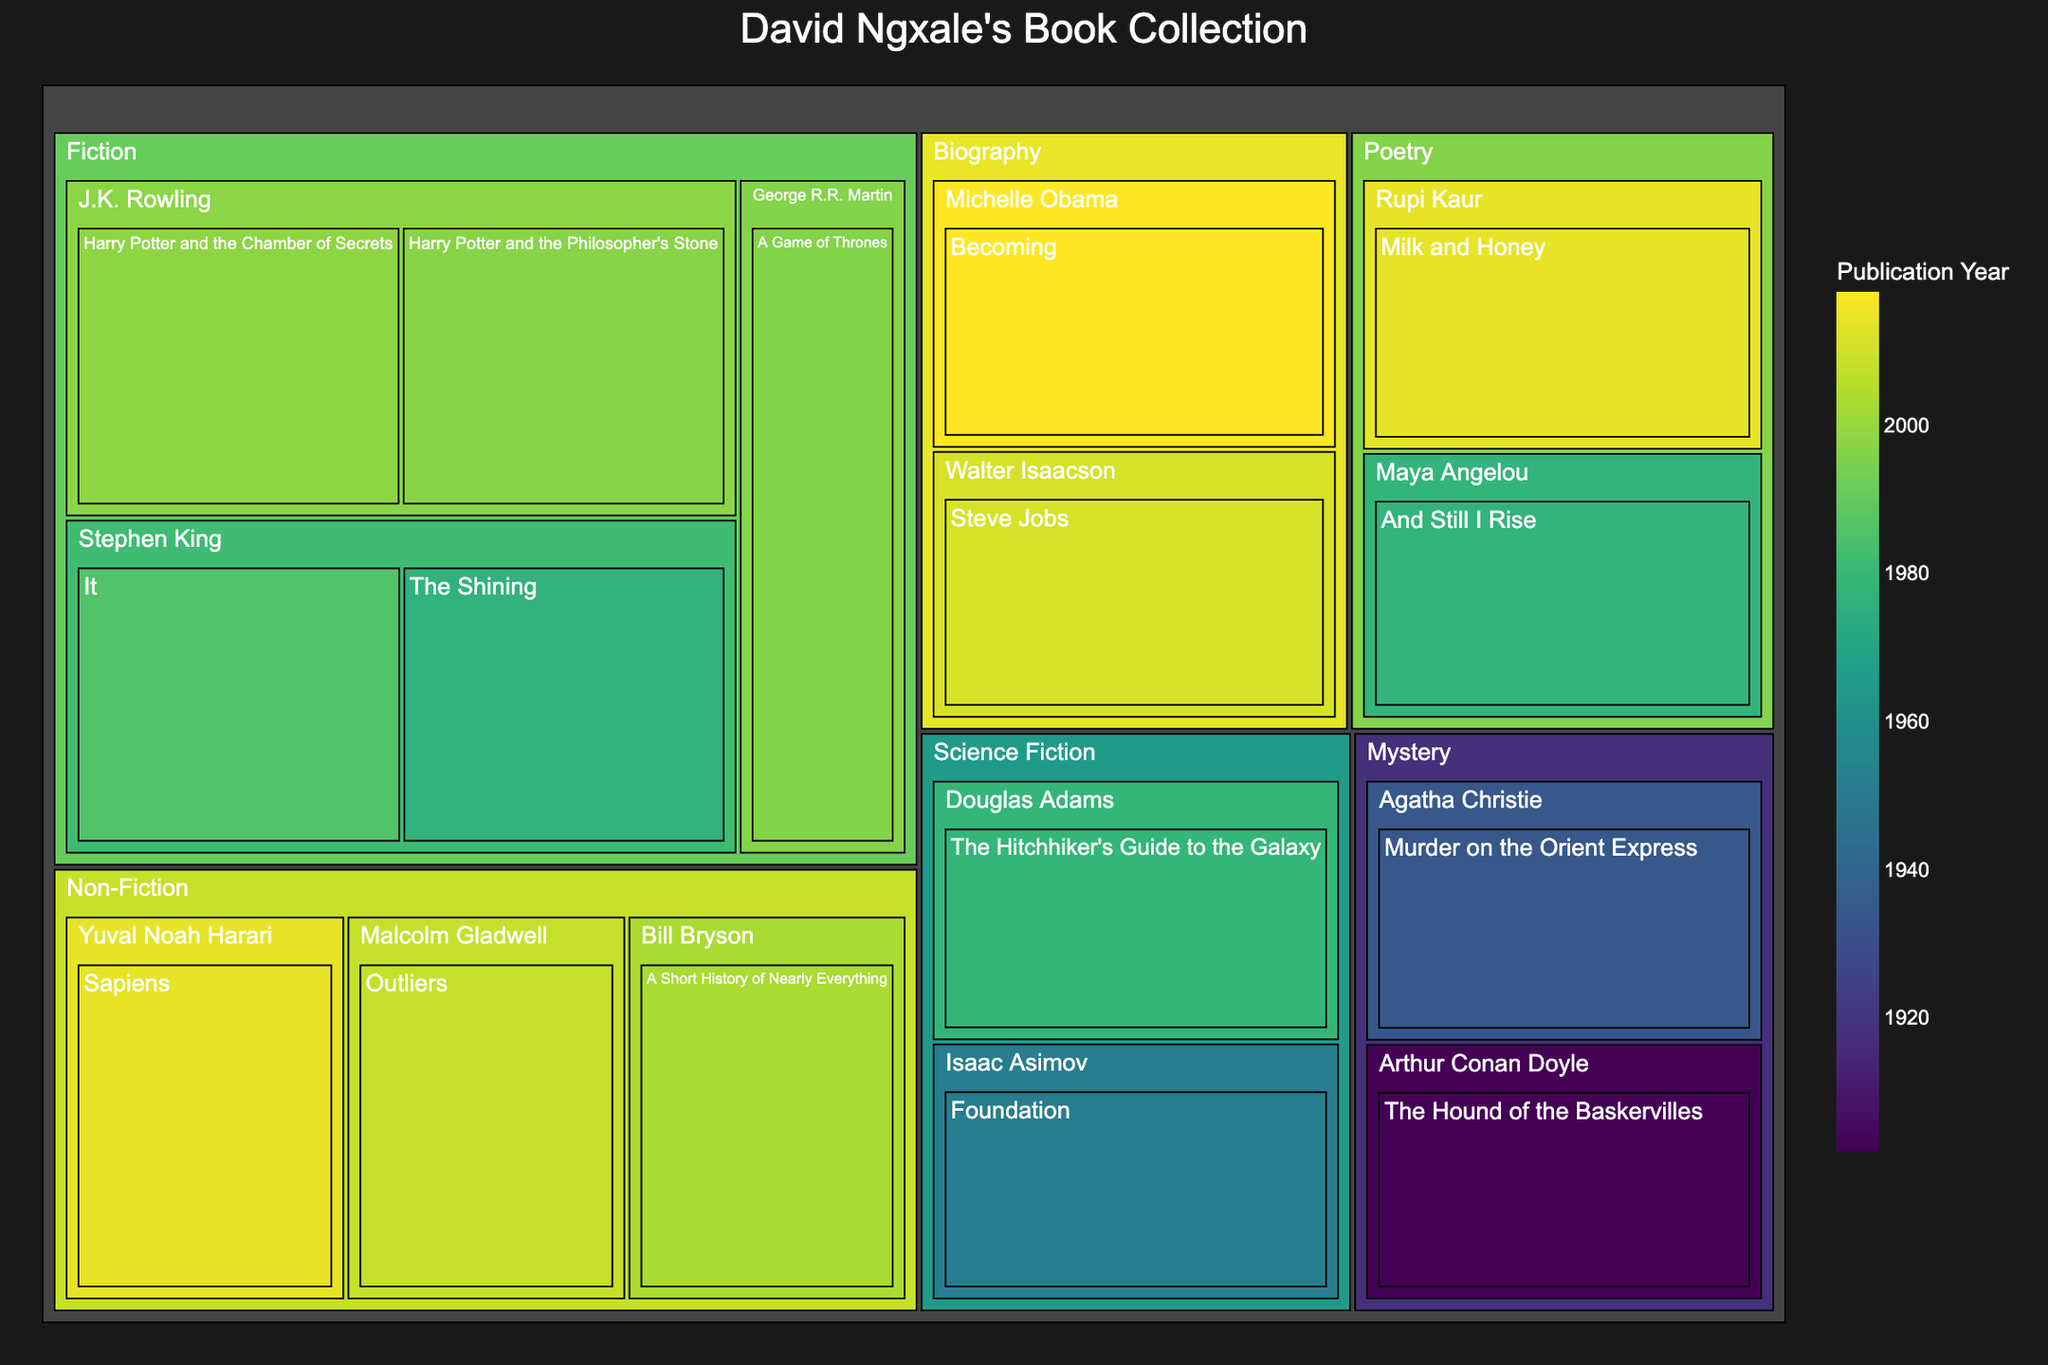What is the title of the treemap? The title of the treemap can be found at the top of the figure, which usually provides an overview of the data being visualized. In this case, it's "David Ngxale's Book Collection".
Answer: David Ngxale's Book Collection Which book was published in the earliest year? By looking at the color gradient and checking the labels, the book with the earliest publication year will typically be at one end of the color spectrum. Here, "The Hound of the Baskervilles" by Arthur Conan Doyle, published in 1902, appears to be the earliest.
Answer: The Hound of the Baskervilles How many genres are represented in David Ngxale's book collection? Genres can be identified by the primary categories in the treemap. By counting these main categories, we find there are six genres: Fiction, Non-Fiction, Poetry, Science Fiction, Mystery, and Biography.
Answer: Six Which genre has the most books published after the year 2000? To answer this, observe the sections in the treemap and note the books' publication years. Fiction contains several books post-2000, including multiple Harry Potter books and newer works by other authors.
Answer: Fiction Which author has the most recent publication in the Poetry genre? By examining the color gradient and labels within the Poetry genre, the most recent book would be the darkest shade and is "Milk and Honey" by Rupi Kaur, published in 2014.
Answer: Rupi Kaur How many books in Fiction are written by Stephen King? Within the Fiction category, identify the authors and count the books under Stephen King's name. There are two: "The Shining" and "It".
Answer: Two Of all the Science Fiction books, which one was published closest to 1980? Observe the Science Fiction section and identify the publication years of the books. "The Hitchhiker's Guide to the Galaxy" by Douglas Adams was published in 1979, very close to 1980.
Answer: The Hitchhiker's Guide to the Galaxy Which genre features the oldest book in the collection? The book with the earliest publication year in the collection belongs to the Mystery genre, "The Hound of the Baskervilles" published in 1902.
Answer: Mystery What is the average publication year of the Non-Fiction books? Sum the publication years of the Non-Fiction books (2008, 2014, 2003) and divide by the number of books. (2008 + 2014 + 2003) / 3 = 2008.33.
Answer: 2008.33 Which two genres combined have the most books? Count the number of books in each genre. Fiction and Non-Fiction together have the most books: Fiction (5) and Non-Fiction (3), totaling eight books.
Answer: Fiction and Non-Fiction 